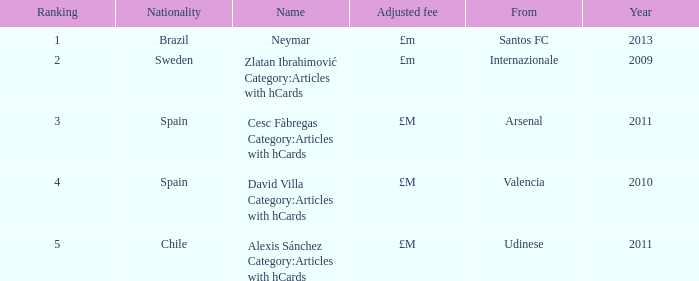What is the homeland of the player ranked 2? Internazionale. 